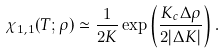<formula> <loc_0><loc_0><loc_500><loc_500>\chi _ { 1 , 1 } ( T ; \rho ) \simeq \frac { 1 } { 2 K } \exp \left ( \frac { K _ { c } \Delta \rho } { 2 | \Delta K | } \right ) .</formula> 